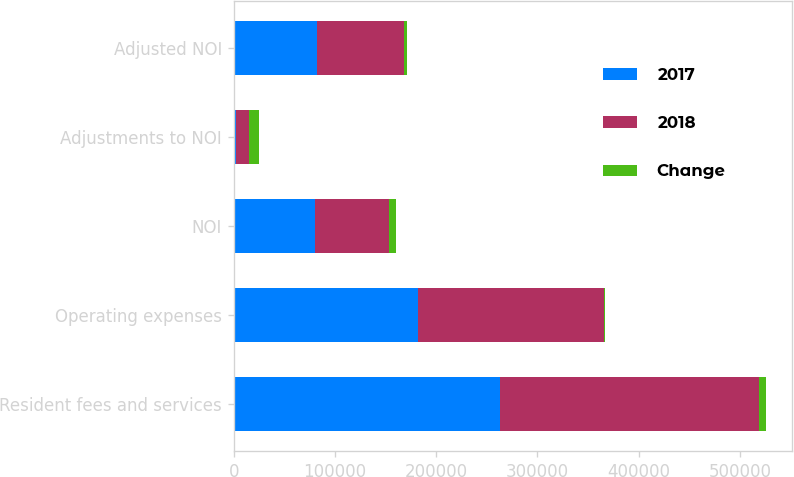<chart> <loc_0><loc_0><loc_500><loc_500><stacked_bar_chart><ecel><fcel>Resident fees and services<fcel>Operating expenses<fcel>NOI<fcel>Adjustments to NOI<fcel>Adjusted NOI<nl><fcel>2017<fcel>262887<fcel>182511<fcel>80376<fcel>2174<fcel>82550<nl><fcel>2018<fcel>256471<fcel>183384<fcel>73087<fcel>12759<fcel>85846<nl><fcel>Change<fcel>6416<fcel>873<fcel>7289<fcel>10585<fcel>3296<nl></chart> 